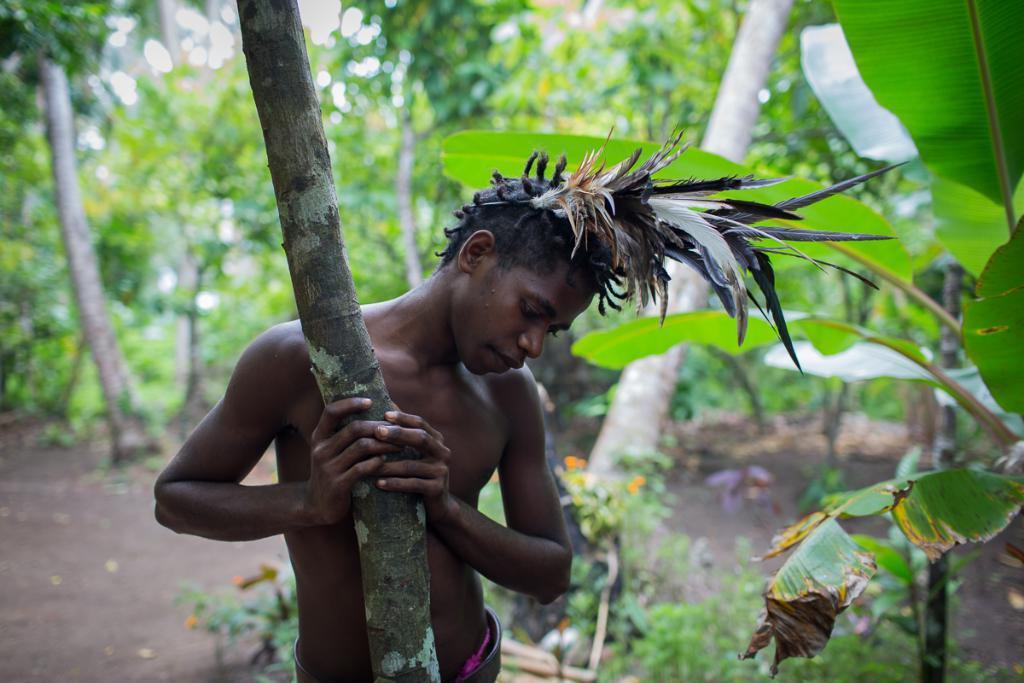Can you describe this image briefly? There is a person wearing a crown made with feathers. And he is holding a tree. In the back there are trees and plants. 